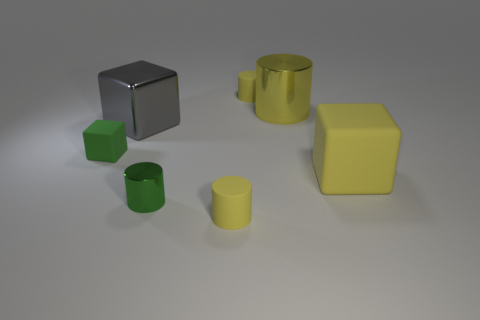Subtract all purple balls. How many yellow cylinders are left? 3 Subtract all red blocks. Subtract all blue cylinders. How many blocks are left? 3 Add 1 tiny shiny cylinders. How many objects exist? 8 Subtract all cubes. How many objects are left? 4 Add 2 purple balls. How many purple balls exist? 2 Subtract 0 red spheres. How many objects are left? 7 Subtract all yellow matte objects. Subtract all big gray metallic things. How many objects are left? 3 Add 4 tiny green objects. How many tiny green objects are left? 6 